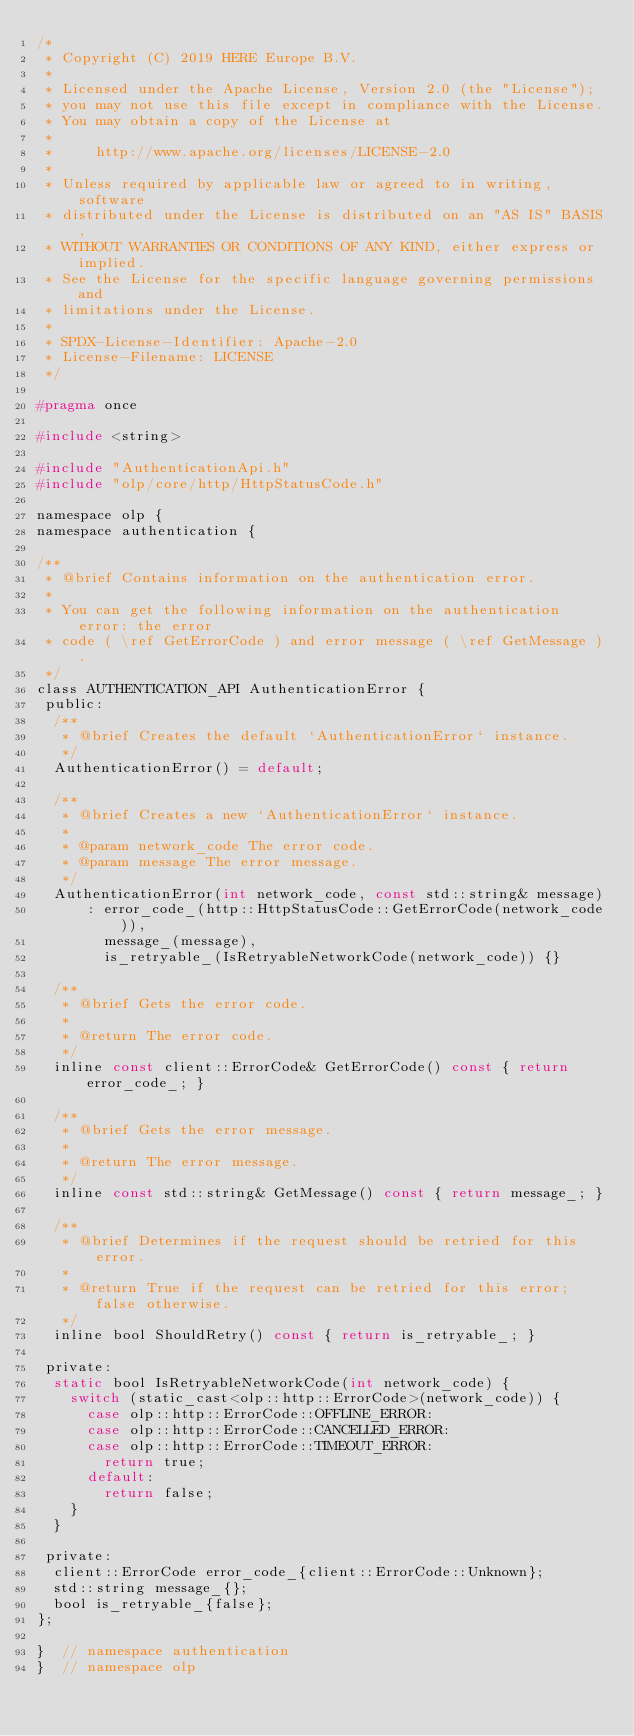Convert code to text. <code><loc_0><loc_0><loc_500><loc_500><_C_>/*
 * Copyright (C) 2019 HERE Europe B.V.
 *
 * Licensed under the Apache License, Version 2.0 (the "License");
 * you may not use this file except in compliance with the License.
 * You may obtain a copy of the License at
 *
 *     http://www.apache.org/licenses/LICENSE-2.0
 *
 * Unless required by applicable law or agreed to in writing, software
 * distributed under the License is distributed on an "AS IS" BASIS,
 * WITHOUT WARRANTIES OR CONDITIONS OF ANY KIND, either express or implied.
 * See the License for the specific language governing permissions and
 * limitations under the License.
 *
 * SPDX-License-Identifier: Apache-2.0
 * License-Filename: LICENSE
 */

#pragma once

#include <string>

#include "AuthenticationApi.h"
#include "olp/core/http/HttpStatusCode.h"

namespace olp {
namespace authentication {

/**
 * @brief Contains information on the authentication error.
 *
 * You can get the following information on the authentication error: the error
 * code ( \ref GetErrorCode ) and error message ( \ref GetMessage ).
 */
class AUTHENTICATION_API AuthenticationError {
 public:
  /**
   * @brief Creates the default `AuthenticationError` instance.
   */
  AuthenticationError() = default;

  /**
   * @brief Creates a new `AuthenticationError` instance.
   * 
   * @param network_code The error code.
   * @param message The error message.
   */
  AuthenticationError(int network_code, const std::string& message)
      : error_code_(http::HttpStatusCode::GetErrorCode(network_code)),
        message_(message),
        is_retryable_(IsRetryableNetworkCode(network_code)) {}

  /**
   * @brief Gets the error code.
   *
   * @return The error code.
   */
  inline const client::ErrorCode& GetErrorCode() const { return error_code_; }

  /**
   * @brief Gets the error message.
   *
   * @return The error message.
   */
  inline const std::string& GetMessage() const { return message_; }

  /**
   * @brief Determines if the request should be retried for this error.
   *
   * @return True if the request can be retried for this error; false otherwise.
   */
  inline bool ShouldRetry() const { return is_retryable_; }

 private:
  static bool IsRetryableNetworkCode(int network_code) {
    switch (static_cast<olp::http::ErrorCode>(network_code)) {
      case olp::http::ErrorCode::OFFLINE_ERROR:
      case olp::http::ErrorCode::CANCELLED_ERROR:
      case olp::http::ErrorCode::TIMEOUT_ERROR:
        return true;
      default:
        return false;
    }
  }

 private:
  client::ErrorCode error_code_{client::ErrorCode::Unknown};
  std::string message_{};
  bool is_retryable_{false};
};

}  // namespace authentication
}  // namespace olp
</code> 